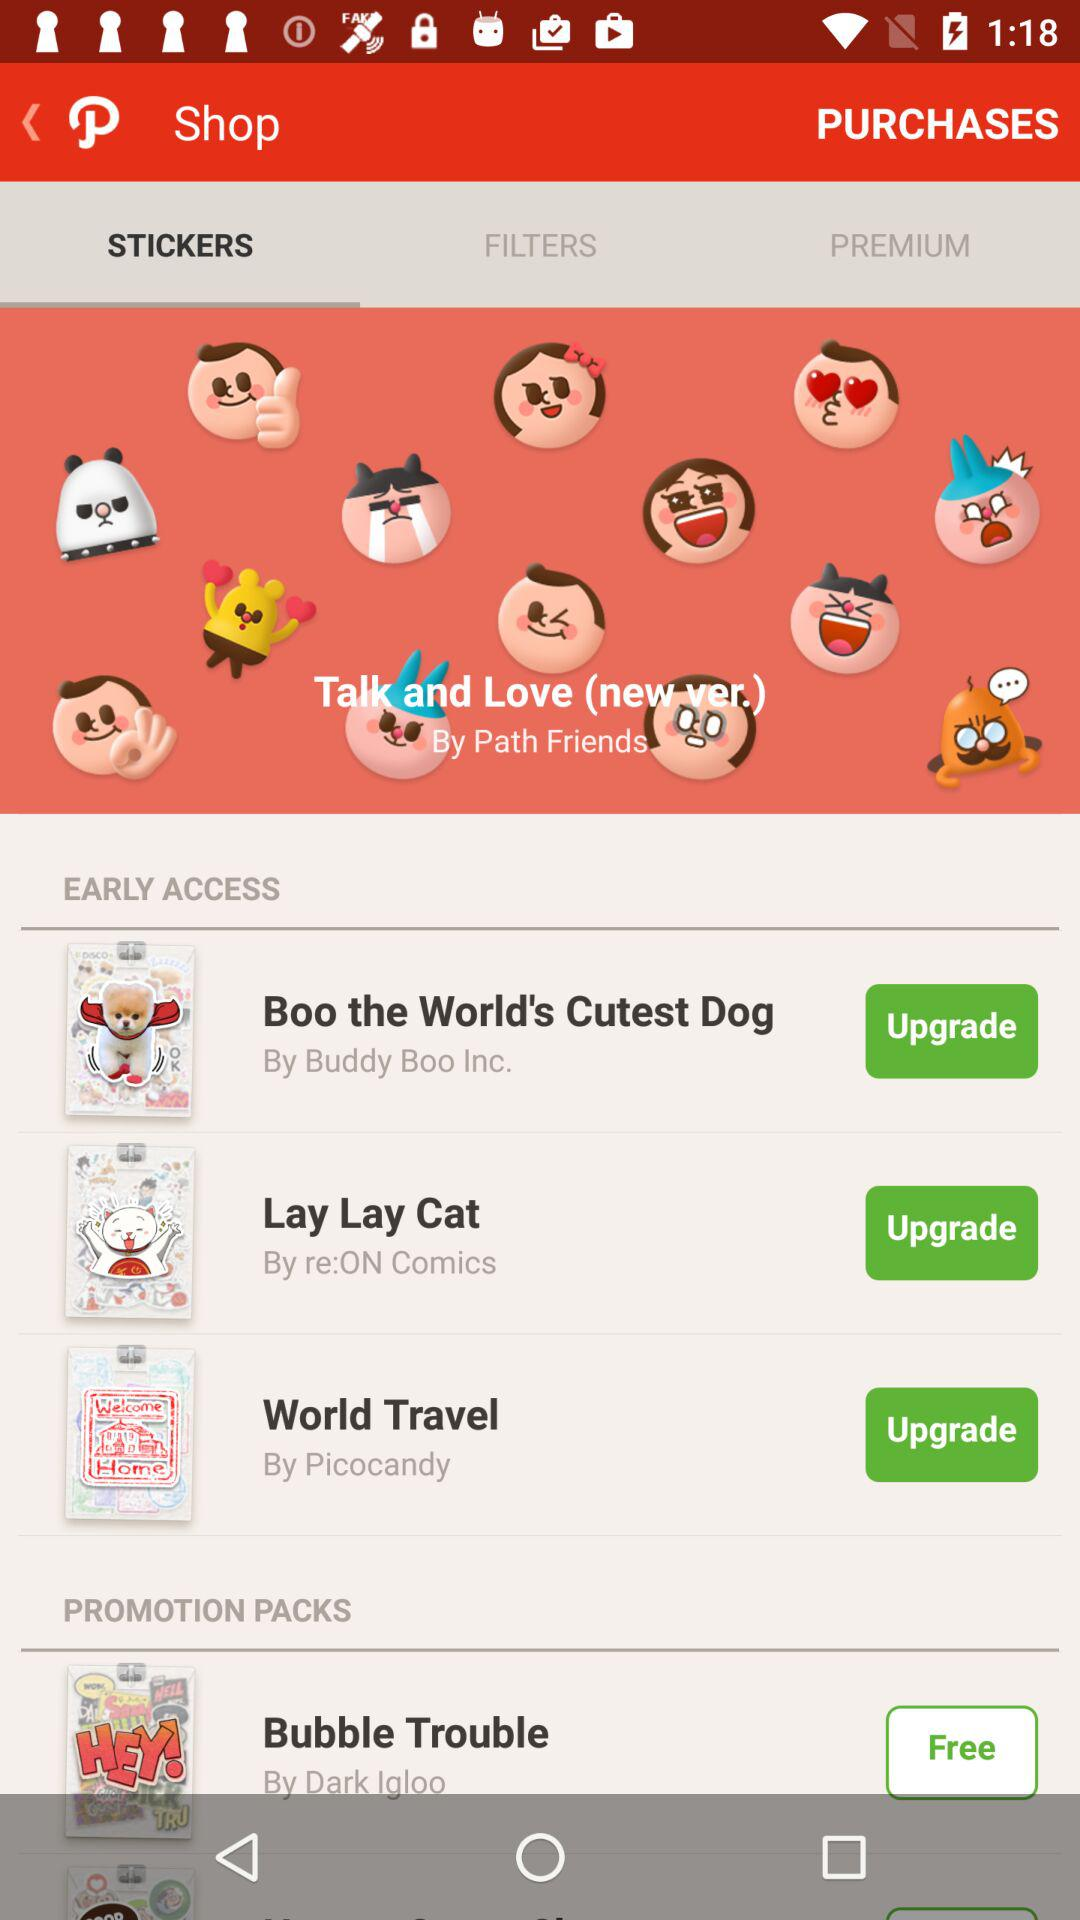What's the name of the new version of stickers? The name of the new version of stickers is "Talk and Love". 